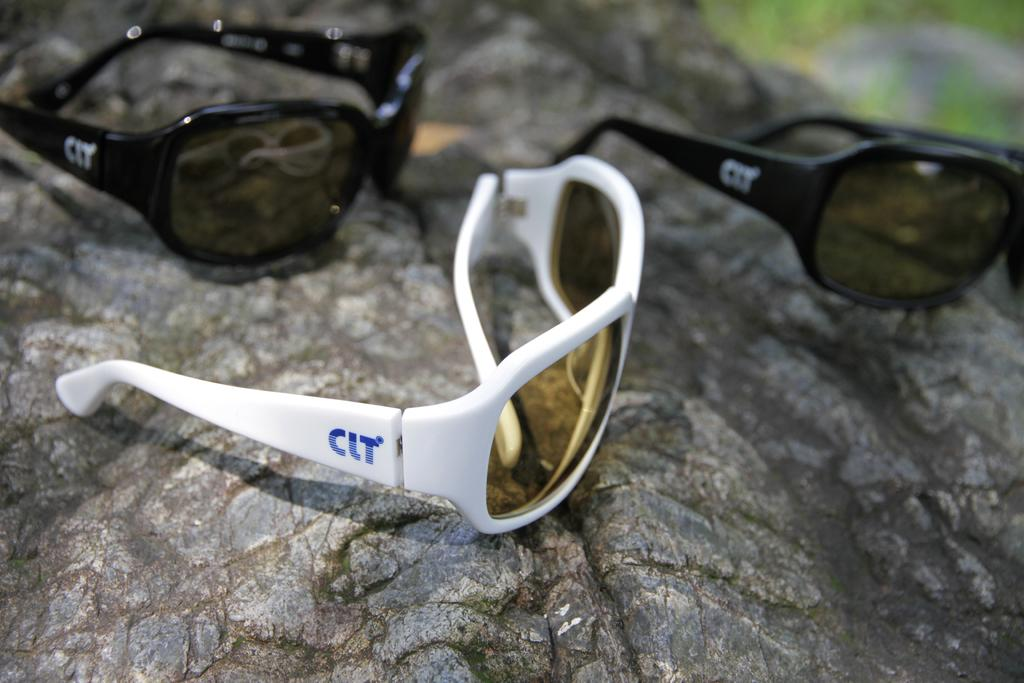What objects are present in the image? There are glasses in the image. How many glasses are black in color? Two of the glasses are black in color. How many glasses are white in color? One of the glasses is white in color. Where are the glasses placed? The glasses are on a rock. What type of tin can be seen in the image? There is no tin present in the image. Is the sister of the person taking the picture visible in the image? There is no information about a sister or any people in the image, so it cannot be determined if the sister is visible. 